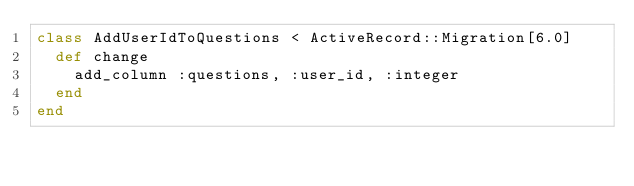Convert code to text. <code><loc_0><loc_0><loc_500><loc_500><_Ruby_>class AddUserIdToQuestions < ActiveRecord::Migration[6.0]
  def change
    add_column :questions, :user_id, :integer
  end
end
</code> 